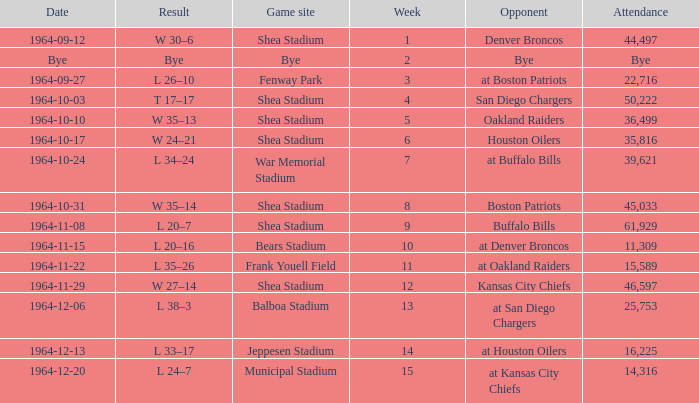Where did the Jet's play with an attendance of 11,309? Bears Stadium. 